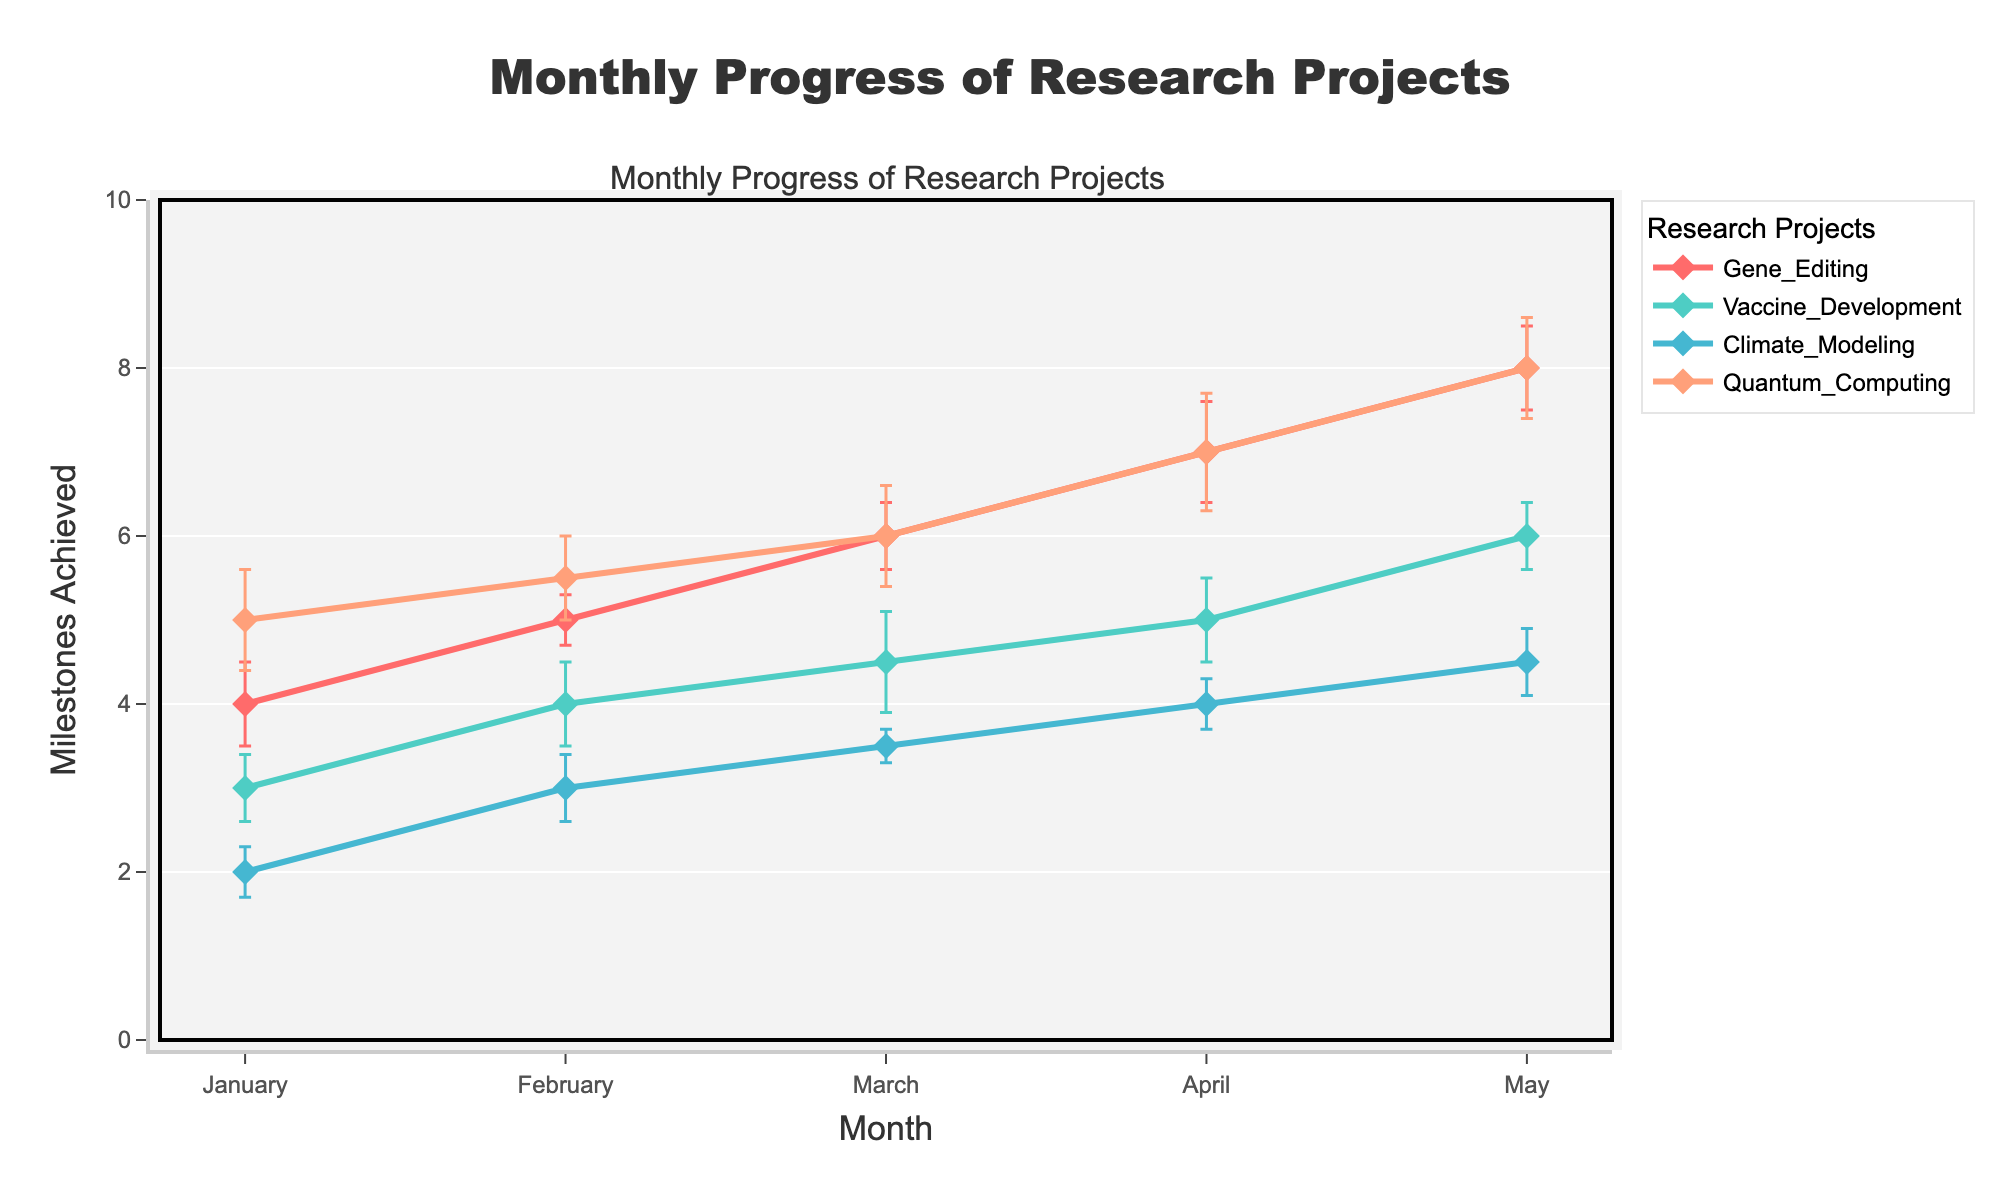What is the title of the figure? The title is usually displayed prominently at the top of the figure. By looking at this area, you can find the text that describes the content of the plot.
Answer: Monthly Progress of Research Projects Which project achieved the highest number of milestones in May? To determine this, check the values in May for each project. Look at the data points corresponding to May and identify the highest value. Quantum_Computing achieved 8 milestones, which is the highest.
Answer: Quantum_Computing What is the range of the y-axis on the figure? The figure's y-axis range starts at the minimum value and ends at the maximum value. The range is usually listed on the y-axis itself. In this figure, it ranges from 0 to 10.
Answer: 0 to 10 How does the progress of Gene_Editing in April compare to Vaccine_Development in the same month? Find the milestones achieved by Gene_Editing and Vaccine_Development in April on the plot. Gene_Editing achieved 7 milestones, while Vaccine_Development achieved 5. Hence, Gene_Editing achieved more milestones.
Answer: Gene_Editing achieved more milestones Which project has the highest standard deviation in March? Check the error bars for different projects in March. The height of the error bars represents the standard deviation. Quantum_Computing has the tallest error bar in March, indicating the highest standard deviation of 0.6.
Answer: Quantum_Computing What is the difference in milestones achieved by Climate_Modeling between January and May? Find the milestones achieved by Climate_Modeling in January (2) and May (4.5). Subtract the January value from the May value to get the difference: 4.5 - 2 = 2.5
Answer: 2.5 Which project showed consistent progress with the least fluctuation in standard deviation over the months? By observing the error bars over the months for each project, note which has the least varying error bars. Vaccine_Development shows more consistent progress with relatively stable and smaller standard deviations compared to others.
Answer: Vaccine_Development Between Gene_Editing and Quantum_Computing, which project had a more significant increase in milestones from January to May? Calculate the difference in milestones from January to May for both projects. Gene_Editing increased from 4 to 8 (difference of 4), and Quantum_Computing from 5 to 8 (difference of 3). Gene_Editing had a more significant increase.
Answer: Gene_Editing What is the combined total of milestones achieved by all projects in February? Sum the February milestones for all projects: Gene_Editing (5) + Vaccine_Development (4) + Climate_Modeling (3) + Quantum_Computing (5.5). The total is 5 + 4 + 3 + 5.5 = 17.5
Answer: 17.5 